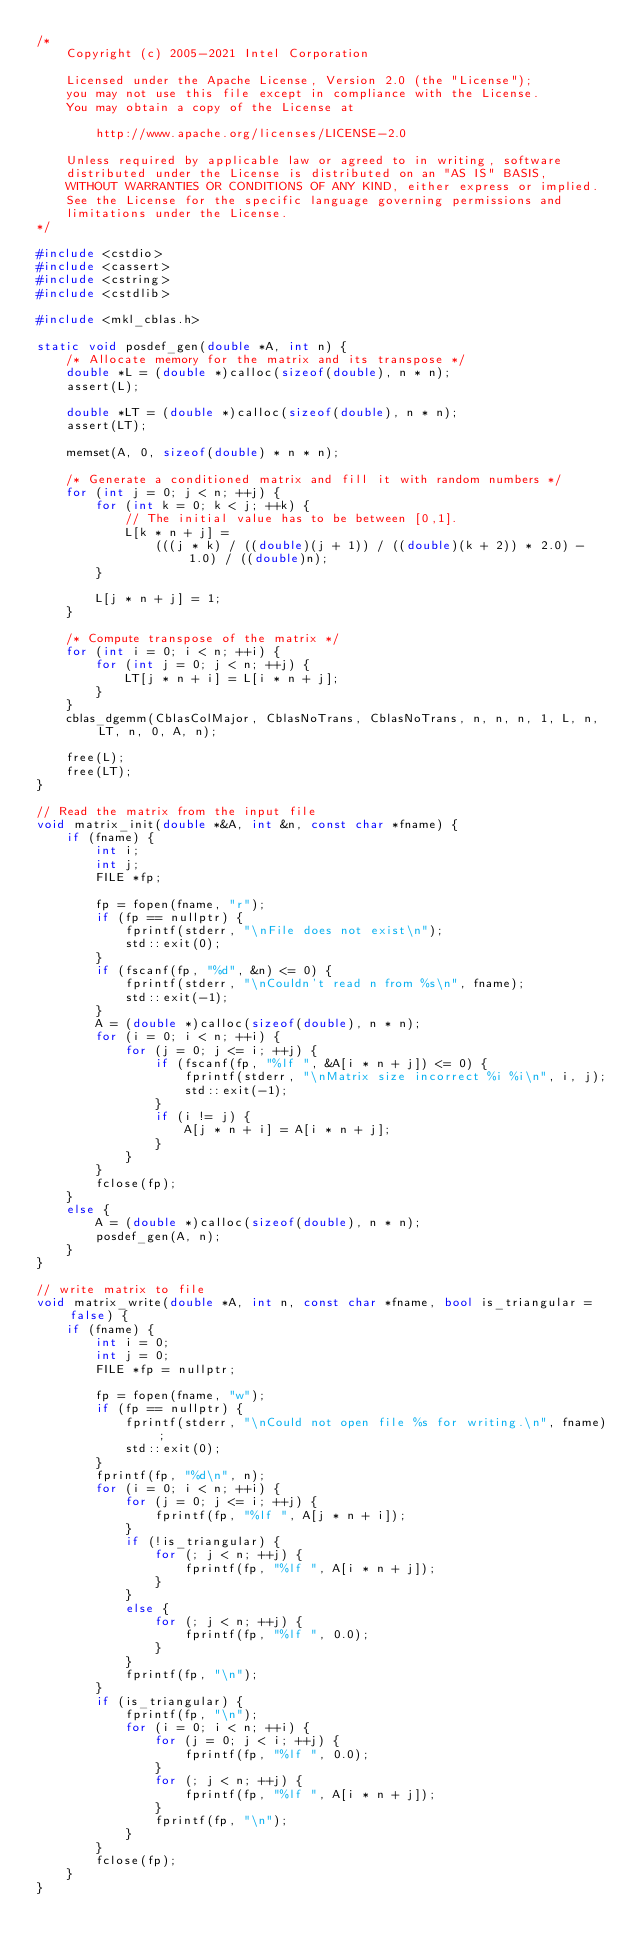<code> <loc_0><loc_0><loc_500><loc_500><_C++_>/*
    Copyright (c) 2005-2021 Intel Corporation

    Licensed under the Apache License, Version 2.0 (the "License");
    you may not use this file except in compliance with the License.
    You may obtain a copy of the License at

        http://www.apache.org/licenses/LICENSE-2.0

    Unless required by applicable law or agreed to in writing, software
    distributed under the License is distributed on an "AS IS" BASIS,
    WITHOUT WARRANTIES OR CONDITIONS OF ANY KIND, either express or implied.
    See the License for the specific language governing permissions and
    limitations under the License.
*/

#include <cstdio>
#include <cassert>
#include <cstring>
#include <cstdlib>

#include <mkl_cblas.h>

static void posdef_gen(double *A, int n) {
    /* Allocate memory for the matrix and its transpose */
    double *L = (double *)calloc(sizeof(double), n * n);
    assert(L);

    double *LT = (double *)calloc(sizeof(double), n * n);
    assert(LT);

    memset(A, 0, sizeof(double) * n * n);

    /* Generate a conditioned matrix and fill it with random numbers */
    for (int j = 0; j < n; ++j) {
        for (int k = 0; k < j; ++k) {
            // The initial value has to be between [0,1].
            L[k * n + j] =
                (((j * k) / ((double)(j + 1)) / ((double)(k + 2)) * 2.0) - 1.0) / ((double)n);
        }

        L[j * n + j] = 1;
    }

    /* Compute transpose of the matrix */
    for (int i = 0; i < n; ++i) {
        for (int j = 0; j < n; ++j) {
            LT[j * n + i] = L[i * n + j];
        }
    }
    cblas_dgemm(CblasColMajor, CblasNoTrans, CblasNoTrans, n, n, n, 1, L, n, LT, n, 0, A, n);

    free(L);
    free(LT);
}

// Read the matrix from the input file
void matrix_init(double *&A, int &n, const char *fname) {
    if (fname) {
        int i;
        int j;
        FILE *fp;

        fp = fopen(fname, "r");
        if (fp == nullptr) {
            fprintf(stderr, "\nFile does not exist\n");
            std::exit(0);
        }
        if (fscanf(fp, "%d", &n) <= 0) {
            fprintf(stderr, "\nCouldn't read n from %s\n", fname);
            std::exit(-1);
        }
        A = (double *)calloc(sizeof(double), n * n);
        for (i = 0; i < n; ++i) {
            for (j = 0; j <= i; ++j) {
                if (fscanf(fp, "%lf ", &A[i * n + j]) <= 0) {
                    fprintf(stderr, "\nMatrix size incorrect %i %i\n", i, j);
                    std::exit(-1);
                }
                if (i != j) {
                    A[j * n + i] = A[i * n + j];
                }
            }
        }
        fclose(fp);
    }
    else {
        A = (double *)calloc(sizeof(double), n * n);
        posdef_gen(A, n);
    }
}

// write matrix to file
void matrix_write(double *A, int n, const char *fname, bool is_triangular = false) {
    if (fname) {
        int i = 0;
        int j = 0;
        FILE *fp = nullptr;

        fp = fopen(fname, "w");
        if (fp == nullptr) {
            fprintf(stderr, "\nCould not open file %s for writing.\n", fname);
            std::exit(0);
        }
        fprintf(fp, "%d\n", n);
        for (i = 0; i < n; ++i) {
            for (j = 0; j <= i; ++j) {
                fprintf(fp, "%lf ", A[j * n + i]);
            }
            if (!is_triangular) {
                for (; j < n; ++j) {
                    fprintf(fp, "%lf ", A[i * n + j]);
                }
            }
            else {
                for (; j < n; ++j) {
                    fprintf(fp, "%lf ", 0.0);
                }
            }
            fprintf(fp, "\n");
        }
        if (is_triangular) {
            fprintf(fp, "\n");
            for (i = 0; i < n; ++i) {
                for (j = 0; j < i; ++j) {
                    fprintf(fp, "%lf ", 0.0);
                }
                for (; j < n; ++j) {
                    fprintf(fp, "%lf ", A[i * n + j]);
                }
                fprintf(fp, "\n");
            }
        }
        fclose(fp);
    }
}
</code> 